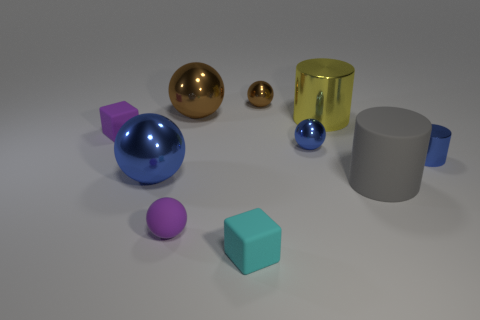The small object that is the same color as the small cylinder is what shape?
Keep it short and to the point. Sphere. There is a purple cube that is made of the same material as the purple sphere; what size is it?
Your answer should be very brief. Small. Is the number of blue metallic cylinders in front of the big yellow object greater than the number of large gray metal things?
Offer a very short reply. Yes. What size is the object that is both in front of the big blue shiny object and right of the tiny cyan rubber cube?
Provide a succinct answer. Large. There is a purple thing that is the same shape as the big blue object; what is it made of?
Your answer should be very brief. Rubber. There is a blue ball to the left of the cyan matte block; is it the same size as the big gray rubber cylinder?
Your answer should be compact. Yes. What color is the metal sphere that is both in front of the purple rubber cube and to the right of the big blue object?
Offer a very short reply. Blue. There is a blue metallic ball that is in front of the tiny blue metallic cylinder; how many tiny things are right of it?
Offer a terse response. 5. Do the gray object and the cyan matte object have the same shape?
Offer a very short reply. No. Are there any other things that are the same color as the matte sphere?
Offer a terse response. Yes. 